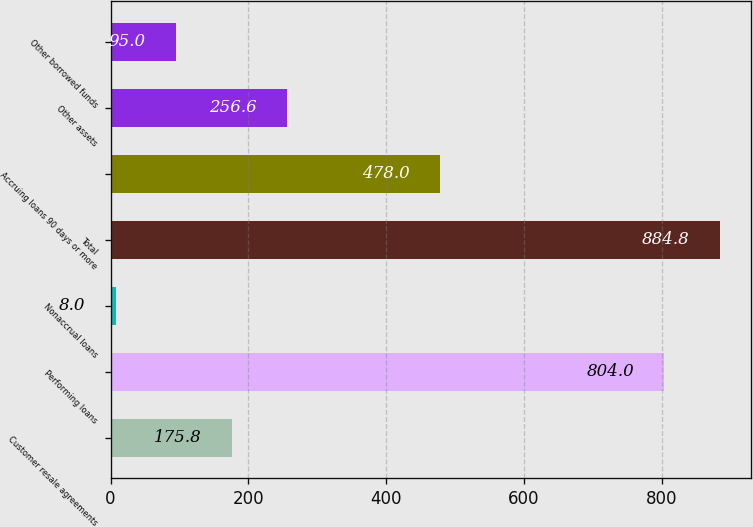<chart> <loc_0><loc_0><loc_500><loc_500><bar_chart><fcel>Customer resale agreements<fcel>Performing loans<fcel>Nonaccrual loans<fcel>Total<fcel>Accruing loans 90 days or more<fcel>Other assets<fcel>Other borrowed funds<nl><fcel>175.8<fcel>804<fcel>8<fcel>884.8<fcel>478<fcel>256.6<fcel>95<nl></chart> 